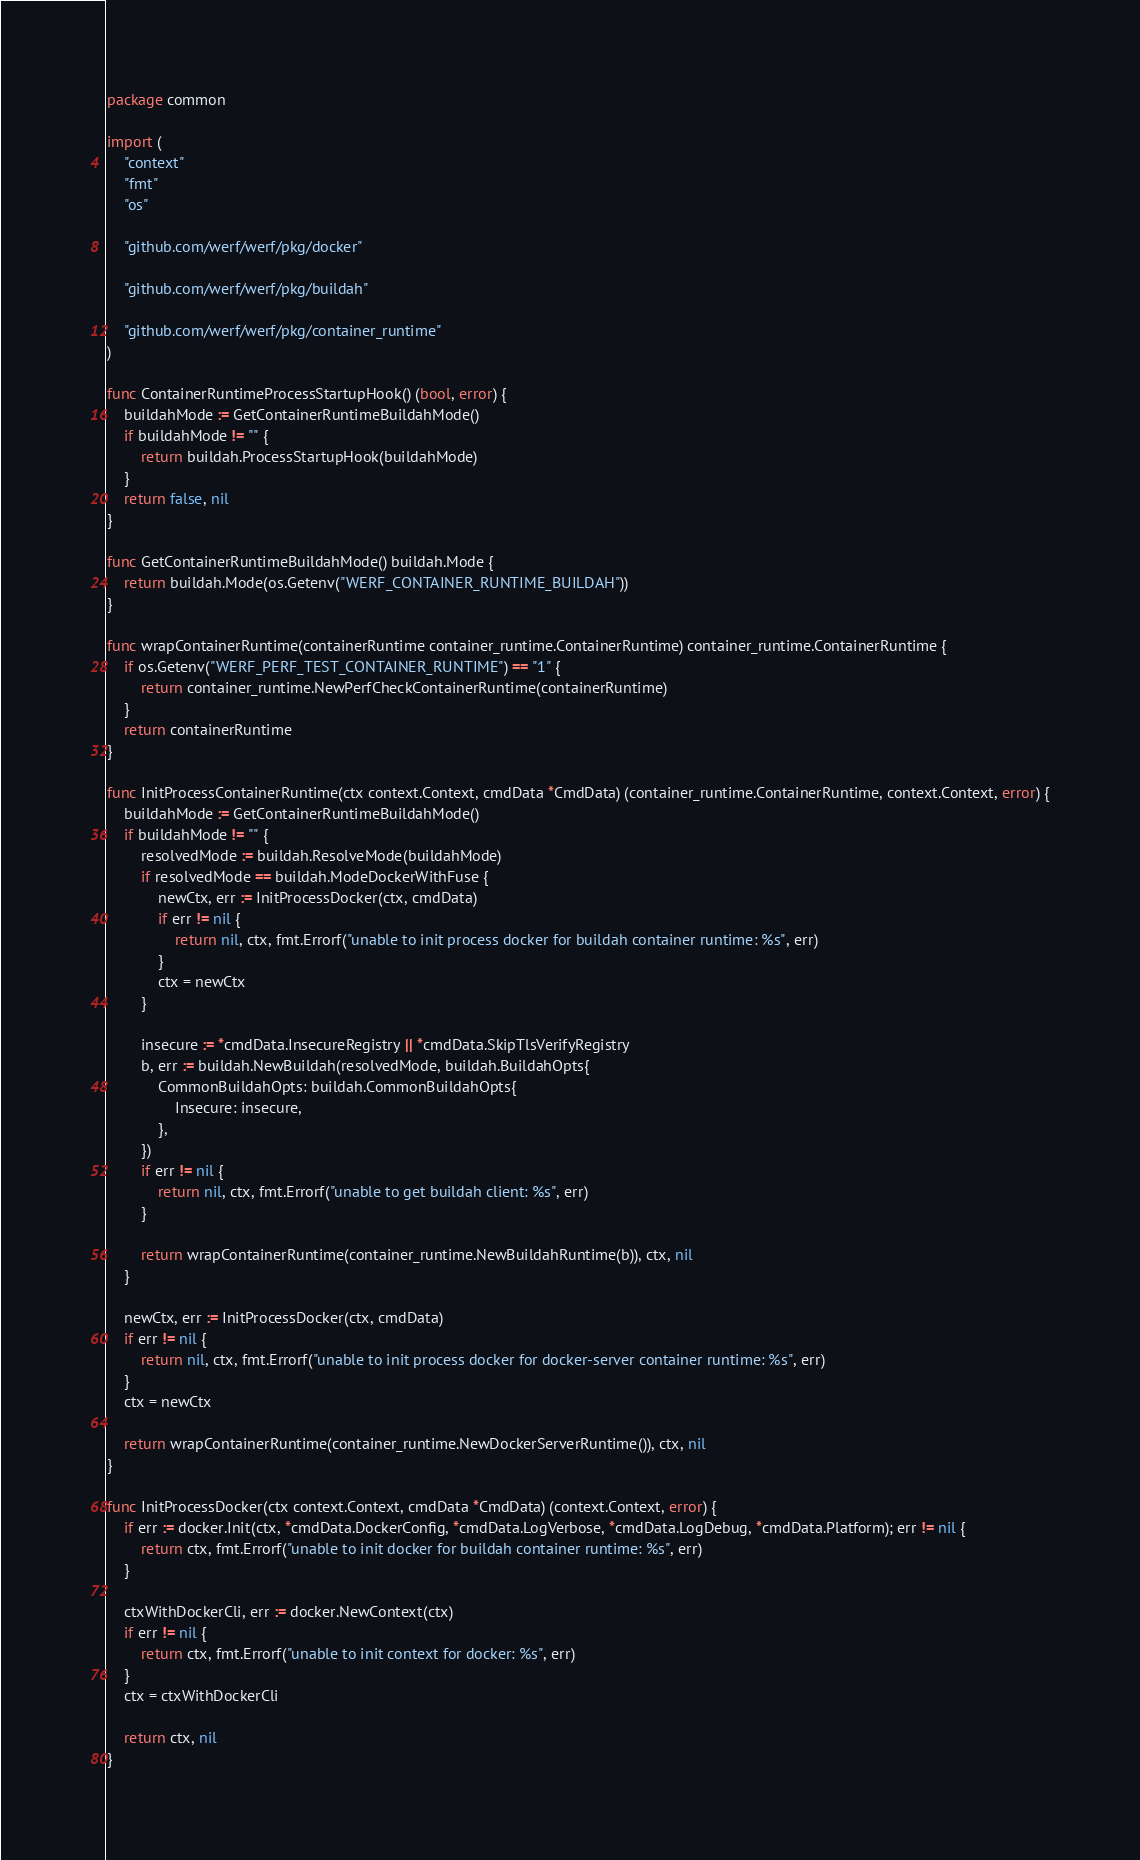<code> <loc_0><loc_0><loc_500><loc_500><_Go_>package common

import (
	"context"
	"fmt"
	"os"

	"github.com/werf/werf/pkg/docker"

	"github.com/werf/werf/pkg/buildah"

	"github.com/werf/werf/pkg/container_runtime"
)

func ContainerRuntimeProcessStartupHook() (bool, error) {
	buildahMode := GetContainerRuntimeBuildahMode()
	if buildahMode != "" {
		return buildah.ProcessStartupHook(buildahMode)
	}
	return false, nil
}

func GetContainerRuntimeBuildahMode() buildah.Mode {
	return buildah.Mode(os.Getenv("WERF_CONTAINER_RUNTIME_BUILDAH"))
}

func wrapContainerRuntime(containerRuntime container_runtime.ContainerRuntime) container_runtime.ContainerRuntime {
	if os.Getenv("WERF_PERF_TEST_CONTAINER_RUNTIME") == "1" {
		return container_runtime.NewPerfCheckContainerRuntime(containerRuntime)
	}
	return containerRuntime
}

func InitProcessContainerRuntime(ctx context.Context, cmdData *CmdData) (container_runtime.ContainerRuntime, context.Context, error) {
	buildahMode := GetContainerRuntimeBuildahMode()
	if buildahMode != "" {
		resolvedMode := buildah.ResolveMode(buildahMode)
		if resolvedMode == buildah.ModeDockerWithFuse {
			newCtx, err := InitProcessDocker(ctx, cmdData)
			if err != nil {
				return nil, ctx, fmt.Errorf("unable to init process docker for buildah container runtime: %s", err)
			}
			ctx = newCtx
		}

		insecure := *cmdData.InsecureRegistry || *cmdData.SkipTlsVerifyRegistry
		b, err := buildah.NewBuildah(resolvedMode, buildah.BuildahOpts{
			CommonBuildahOpts: buildah.CommonBuildahOpts{
				Insecure: insecure,
			},
		})
		if err != nil {
			return nil, ctx, fmt.Errorf("unable to get buildah client: %s", err)
		}

		return wrapContainerRuntime(container_runtime.NewBuildahRuntime(b)), ctx, nil
	}

	newCtx, err := InitProcessDocker(ctx, cmdData)
	if err != nil {
		return nil, ctx, fmt.Errorf("unable to init process docker for docker-server container runtime: %s", err)
	}
	ctx = newCtx

	return wrapContainerRuntime(container_runtime.NewDockerServerRuntime()), ctx, nil
}

func InitProcessDocker(ctx context.Context, cmdData *CmdData) (context.Context, error) {
	if err := docker.Init(ctx, *cmdData.DockerConfig, *cmdData.LogVerbose, *cmdData.LogDebug, *cmdData.Platform); err != nil {
		return ctx, fmt.Errorf("unable to init docker for buildah container runtime: %s", err)
	}

	ctxWithDockerCli, err := docker.NewContext(ctx)
	if err != nil {
		return ctx, fmt.Errorf("unable to init context for docker: %s", err)
	}
	ctx = ctxWithDockerCli

	return ctx, nil
}
</code> 